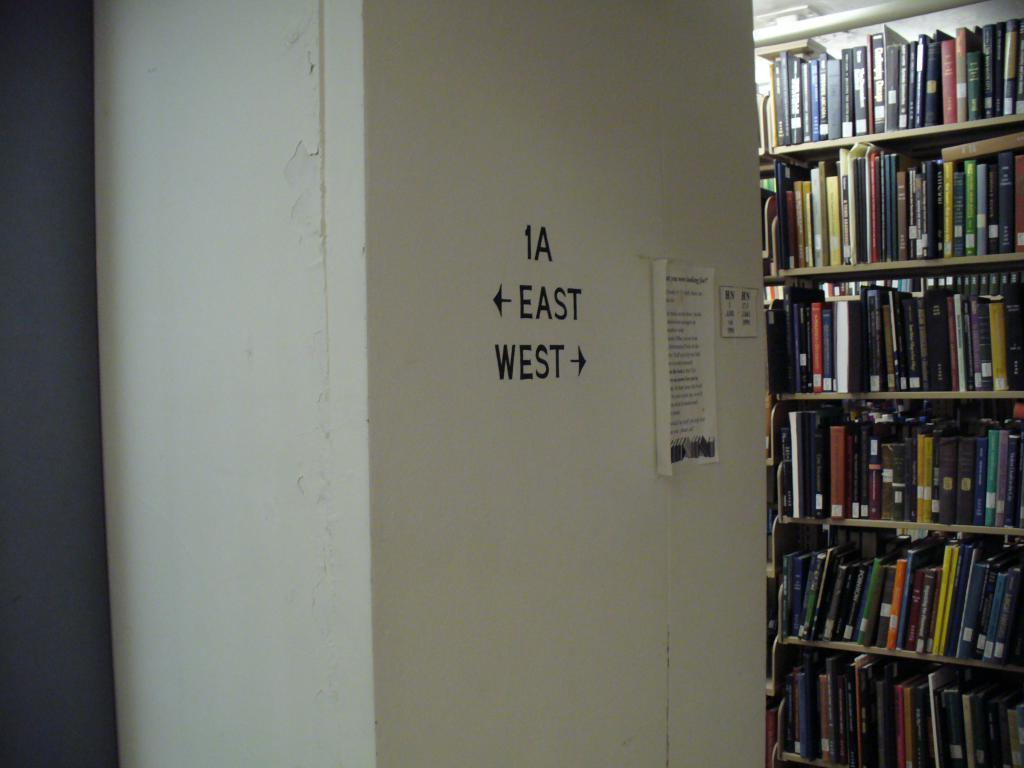Provide a one-sentence caption for the provided image. the interior of a library with 1A East West on a pillar. 